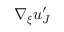<formula> <loc_0><loc_0><loc_500><loc_500>\nabla _ { \xi } u _ { J } ^ { \prime }</formula> 